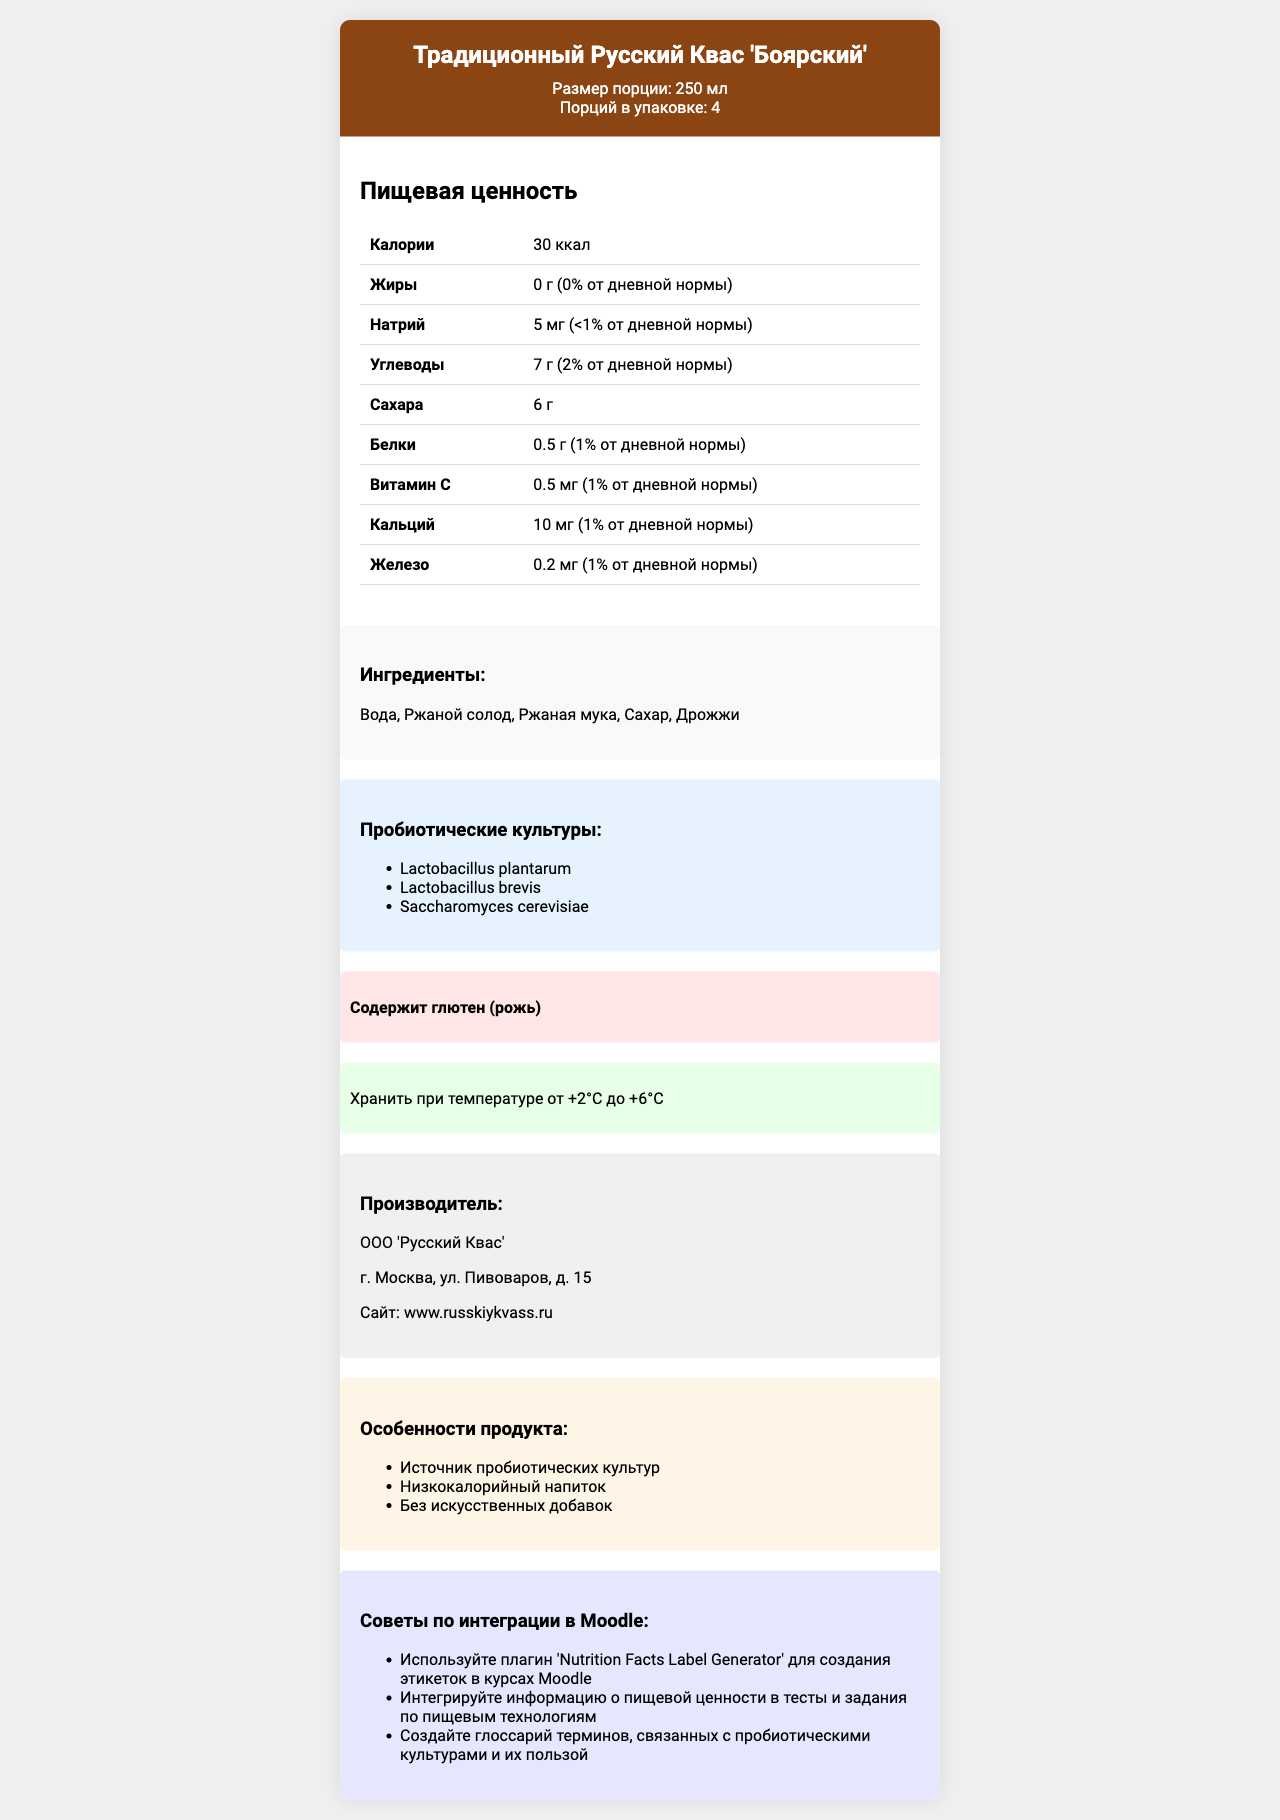what is the serving size of the product? The serving size is explicitly mentioned in the header section of the document.
Answer: 250 мл how many calories are there per serving? The calories per serving are listed as 30 ккал in the nutrition facts section.
Answer: 30 ккал what ingredient in the product contains gluten? The allergen information states that the product contains gluten from rye, and rye malt (ржаной солод) is an ingredient in the list.
Answer: Ржаной солод which vitamin and its amount and daily value percentage is listed? The nutrition facts section lists Vitamin C with an amount of 0.5 мг and a daily value percentage of 1%.
Answer: Витамин C - 0.5 мг (1% от дневной нормы) list any three probiotic cultures present in the product The probiotic cultures section mentions these three cultures explicitly.
Answer: Lactobacillus plantarum, Lactobacillus brevis, Saccharomyces cerevisiae how many servings are there in the container? A. 2 B. 4 C. 5 The header section indicates that there are 4 servings per container.
Answer: B what is the total carbohydrate amount per serving? A. 5 г B. 6 г C. 7 г D. 8 г The nutrition facts section states that the total carbohydrate amount per serving is 7 г.
Answer: C is the product considered low-calorie? The nutritional claims section in Russian states "Низкокалорийный напиток", which translates to "Low-calorie beverage".
Answer: Yes summary of the document The detailed document layout starts with the product name and serving details, followed by nutrition facts in a table, ingredients list, probiotic cultures, allergen information, storage instructions, manufacturer info, nutritional claims, and Moodle integration tips for broader usage in educational contexts.
Answer: The document is a nutrition facts label for "Традиционный Русский Квас 'Боярский'", including serving size, servings per container, and detailed nutritional information per serving such as calories, fats, sodium, carbohydrates, sugars, protein, vitamins, and minerals. It also lists ingredients, probiotic cultures, allergen information, storage instructions, manufacturer details, nutritional claims, and tips for Moodle integration. what is the exact address of the manufacturer? The manufacturer information clearly lists the address as "г. Москва, ул. Пивоваров, д. 15".
Answer: Москва, ул. Пивоваров, д. 15 what is the website of the manufacturer? The website for the manufacturer is specified in the manufacturer information section.
Answer: www.russkiykvass.ru where should the product be stored? The storage instructions section mentions that the product should be stored at temperatures between +2°C and +6°C.
Answer: При температуре от +2°C до +6°C does the product contain artificial additives? The nutritional claims section states "Без искусственных добавок", which translates to "No artificial additives".
Answer: No who developed the Moodle integration tips listed in the document? The document includes Moodle integration tips but does not specify who developed them, so this information cannot be determined.
Answer: Cannot be determined 